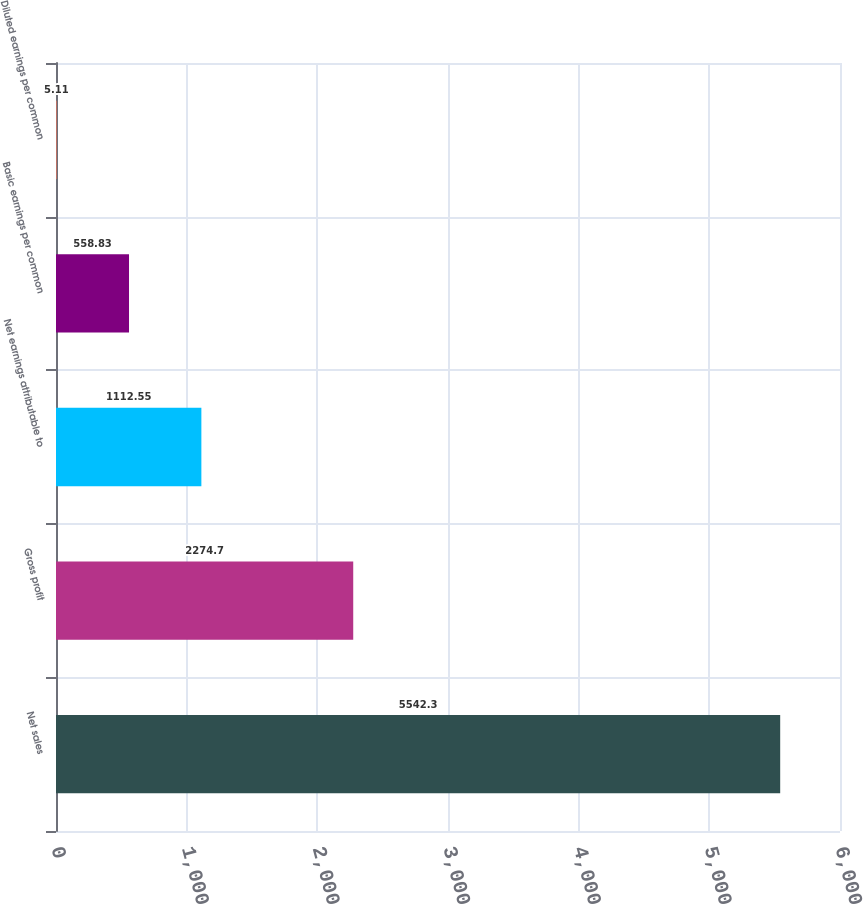<chart> <loc_0><loc_0><loc_500><loc_500><bar_chart><fcel>Net sales<fcel>Gross profit<fcel>Net earnings attributable to<fcel>Basic earnings per common<fcel>Diluted earnings per common<nl><fcel>5542.3<fcel>2274.7<fcel>1112.55<fcel>558.83<fcel>5.11<nl></chart> 